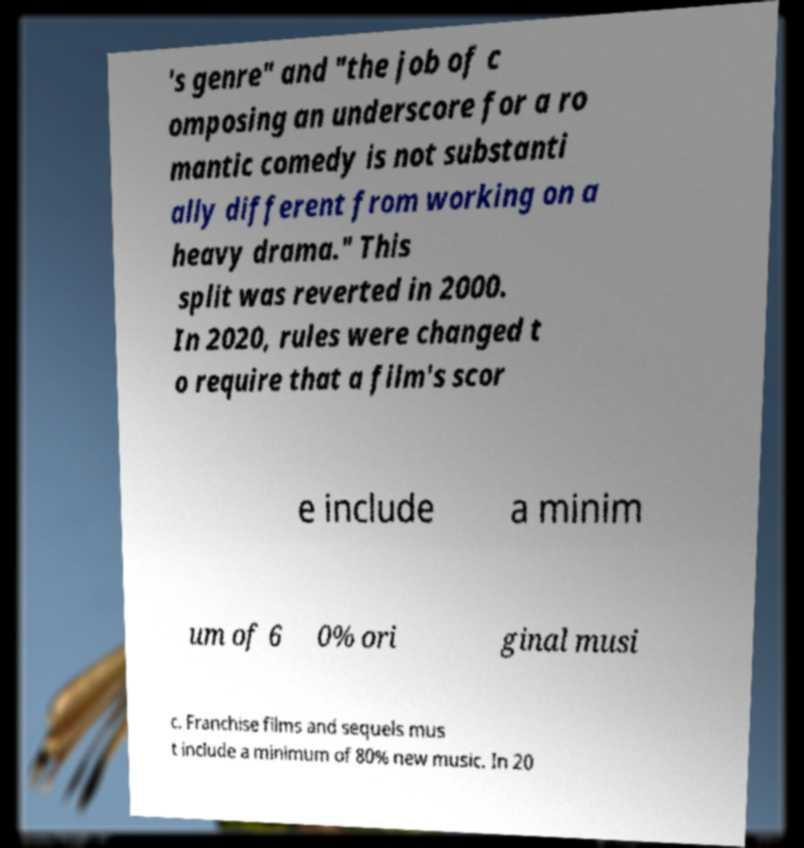For documentation purposes, I need the text within this image transcribed. Could you provide that? 's genre" and "the job of c omposing an underscore for a ro mantic comedy is not substanti ally different from working on a heavy drama." This split was reverted in 2000. In 2020, rules were changed t o require that a film's scor e include a minim um of 6 0% ori ginal musi c. Franchise films and sequels mus t include a minimum of 80% new music. In 20 